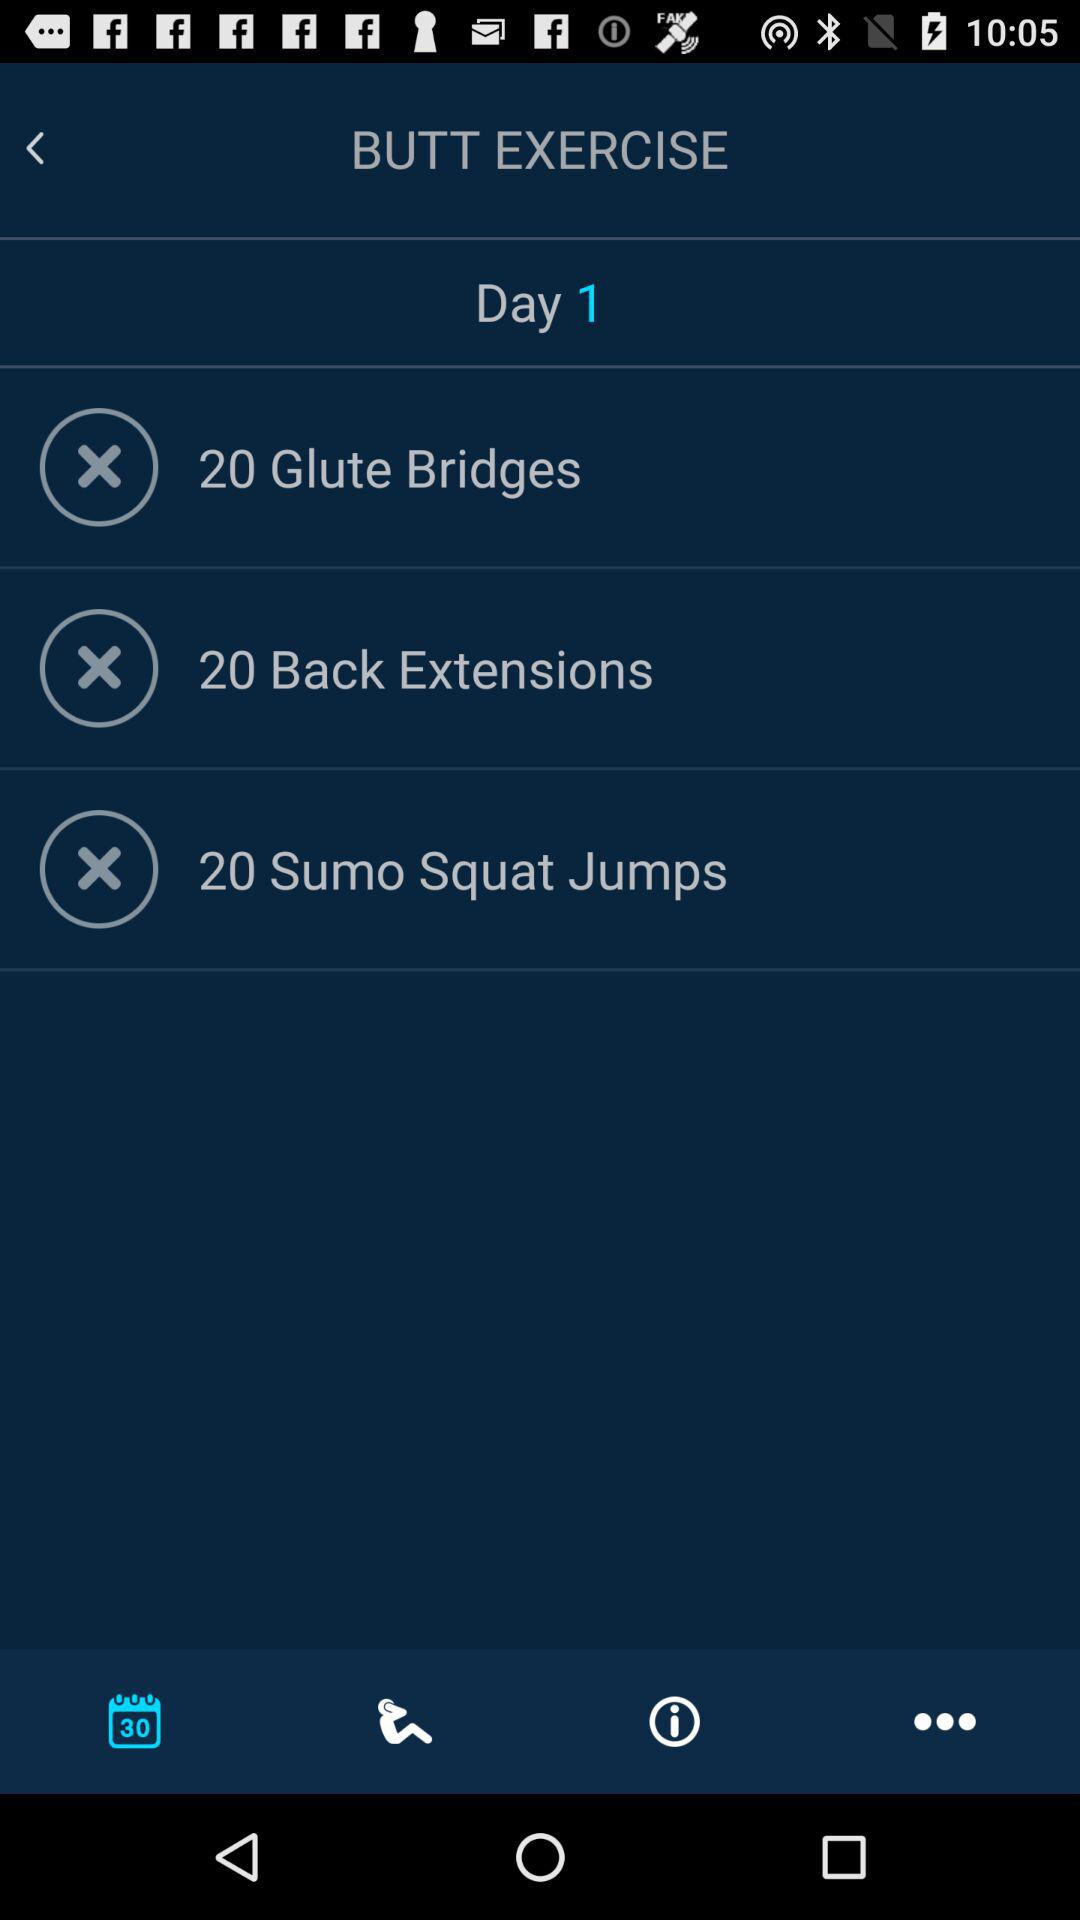How many more Back Extensions than Glute Bridges are there?
Answer the question using a single word or phrase. 0 